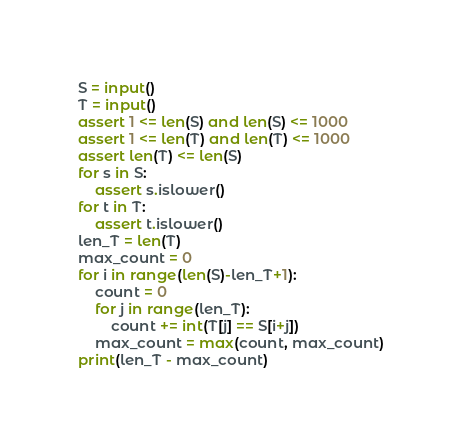<code> <loc_0><loc_0><loc_500><loc_500><_Python_>S = input()
T = input()
assert 1 <= len(S) and len(S) <= 1000
assert 1 <= len(T) and len(T) <= 1000
assert len(T) <= len(S)
for s in S:
    assert s.islower()
for t in T:
    assert t.islower()
len_T = len(T)
max_count = 0
for i in range(len(S)-len_T+1):
    count = 0
    for j in range(len_T):
        count += int(T[j] == S[i+j]) 
    max_count = max(count, max_count)
print(len_T - max_count)</code> 